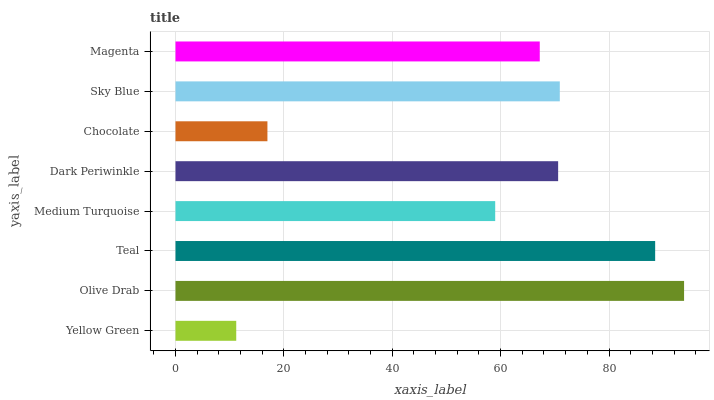Is Yellow Green the minimum?
Answer yes or no. Yes. Is Olive Drab the maximum?
Answer yes or no. Yes. Is Teal the minimum?
Answer yes or no. No. Is Teal the maximum?
Answer yes or no. No. Is Olive Drab greater than Teal?
Answer yes or no. Yes. Is Teal less than Olive Drab?
Answer yes or no. Yes. Is Teal greater than Olive Drab?
Answer yes or no. No. Is Olive Drab less than Teal?
Answer yes or no. No. Is Dark Periwinkle the high median?
Answer yes or no. Yes. Is Magenta the low median?
Answer yes or no. Yes. Is Sky Blue the high median?
Answer yes or no. No. Is Teal the low median?
Answer yes or no. No. 